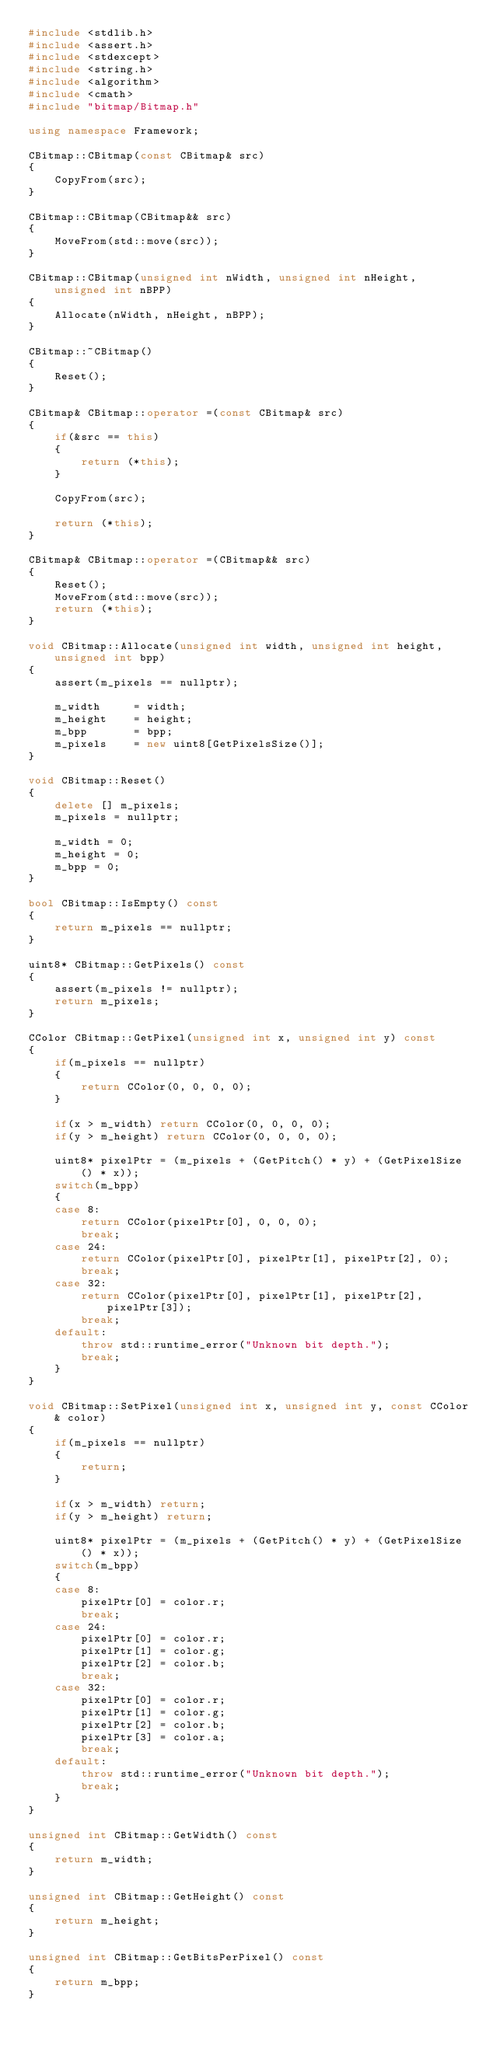Convert code to text. <code><loc_0><loc_0><loc_500><loc_500><_C++_>#include <stdlib.h>
#include <assert.h>
#include <stdexcept>
#include <string.h>
#include <algorithm>
#include <cmath>
#include "bitmap/Bitmap.h"

using namespace Framework;

CBitmap::CBitmap(const CBitmap& src)
{
	CopyFrom(src);
}

CBitmap::CBitmap(CBitmap&& src)
{
	MoveFrom(std::move(src));
}

CBitmap::CBitmap(unsigned int nWidth, unsigned int nHeight, unsigned int nBPP)
{
	Allocate(nWidth, nHeight, nBPP);
}

CBitmap::~CBitmap()
{
	Reset();
}

CBitmap& CBitmap::operator =(const CBitmap& src)
{
	if(&src == this)
	{
		return (*this);
	}

	CopyFrom(src);

	return (*this);
}

CBitmap& CBitmap::operator =(CBitmap&& src)
{
	Reset();
	MoveFrom(std::move(src));
	return (*this);
}

void CBitmap::Allocate(unsigned int width, unsigned int height, unsigned int bpp)
{
	assert(m_pixels == nullptr);

	m_width		= width;
	m_height	= height;
	m_bpp		= bpp;
	m_pixels	= new uint8[GetPixelsSize()];
}

void CBitmap::Reset()
{
	delete [] m_pixels;
	m_pixels = nullptr;

	m_width = 0;
	m_height = 0;
	m_bpp = 0;
}

bool CBitmap::IsEmpty() const
{
	return m_pixels == nullptr;
}

uint8* CBitmap::GetPixels() const
{
	assert(m_pixels != nullptr);
	return m_pixels;
}

CColor CBitmap::GetPixel(unsigned int x, unsigned int y) const
{
	if(m_pixels == nullptr)
	{
		return CColor(0, 0, 0, 0);
	}

	if(x > m_width) return CColor(0, 0, 0, 0);
	if(y > m_height) return CColor(0, 0, 0, 0);

	uint8* pixelPtr = (m_pixels + (GetPitch() * y) + (GetPixelSize() * x));
	switch(m_bpp)
	{
	case 8:
		return CColor(pixelPtr[0], 0, 0, 0);
		break;
	case 24:
		return CColor(pixelPtr[0], pixelPtr[1], pixelPtr[2], 0);
		break;
	case 32:
		return CColor(pixelPtr[0], pixelPtr[1], pixelPtr[2], pixelPtr[3]);
		break;
	default:
		throw std::runtime_error("Unknown bit depth.");
		break;
	}
}

void CBitmap::SetPixel(unsigned int x, unsigned int y, const CColor& color)
{
	if(m_pixels == nullptr)
	{
		return;
	}

	if(x > m_width) return;
	if(y > m_height) return;

	uint8* pixelPtr = (m_pixels + (GetPitch() * y) + (GetPixelSize() * x));
	switch(m_bpp)
	{
	case 8:
		pixelPtr[0] = color.r;
		break;
	case 24:
		pixelPtr[0] = color.r;
		pixelPtr[1] = color.g;
		pixelPtr[2] = color.b;
		break;
	case 32:
		pixelPtr[0] = color.r;
		pixelPtr[1] = color.g;
		pixelPtr[2] = color.b;
		pixelPtr[3] = color.a;
		break;
	default:
		throw std::runtime_error("Unknown bit depth.");
		break;
	}
}

unsigned int CBitmap::GetWidth() const
{
	return m_width;
}

unsigned int CBitmap::GetHeight() const
{
	return m_height;
}

unsigned int CBitmap::GetBitsPerPixel() const
{
	return m_bpp;
}
</code> 